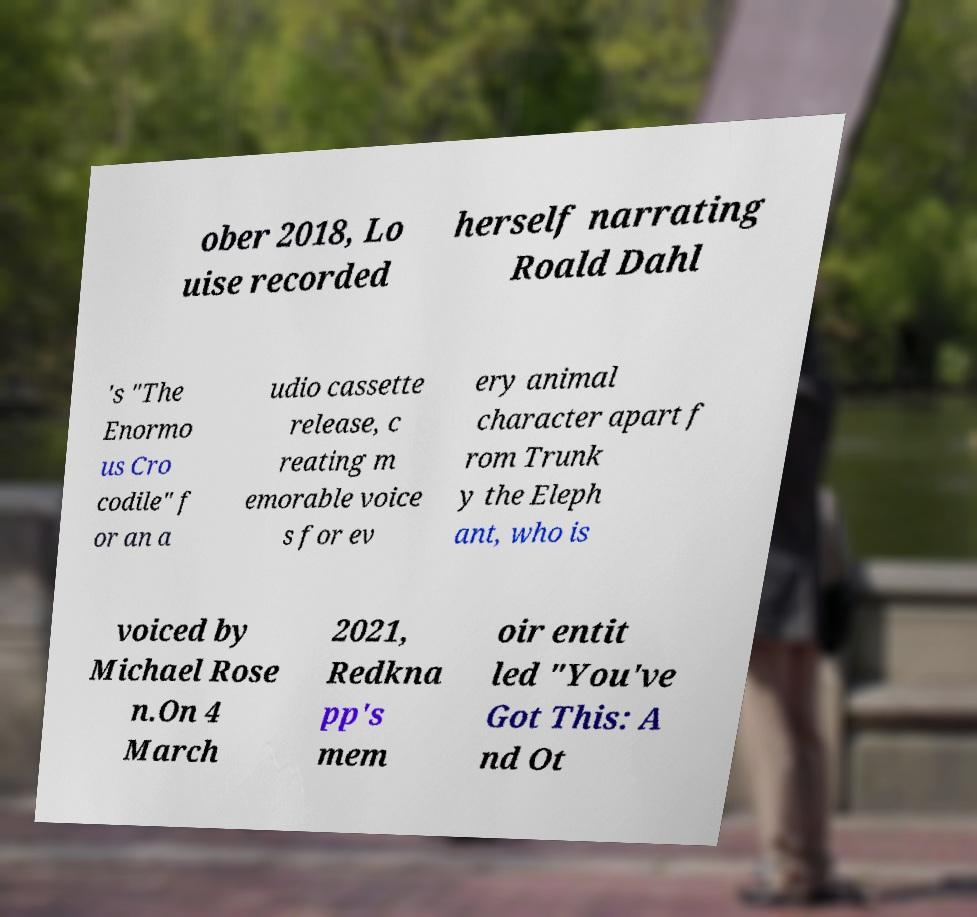I need the written content from this picture converted into text. Can you do that? ober 2018, Lo uise recorded herself narrating Roald Dahl 's "The Enormo us Cro codile" f or an a udio cassette release, c reating m emorable voice s for ev ery animal character apart f rom Trunk y the Eleph ant, who is voiced by Michael Rose n.On 4 March 2021, Redkna pp's mem oir entit led "You've Got This: A nd Ot 